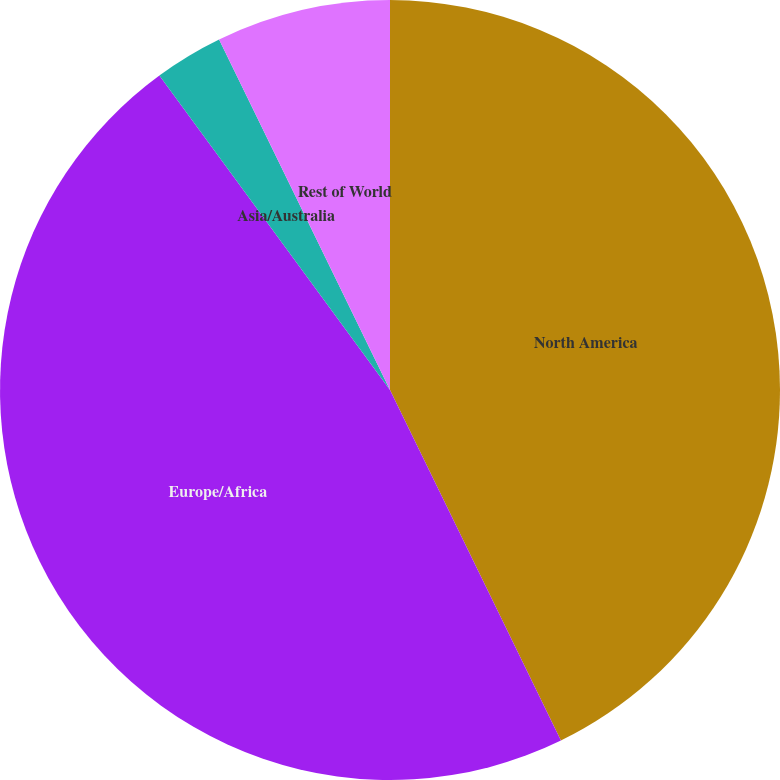Convert chart to OTSL. <chart><loc_0><loc_0><loc_500><loc_500><pie_chart><fcel>North America<fcel>Europe/Africa<fcel>Asia/Australia<fcel>Rest of World<nl><fcel>42.78%<fcel>47.15%<fcel>2.85%<fcel>7.22%<nl></chart> 